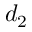<formula> <loc_0><loc_0><loc_500><loc_500>d _ { 2 }</formula> 